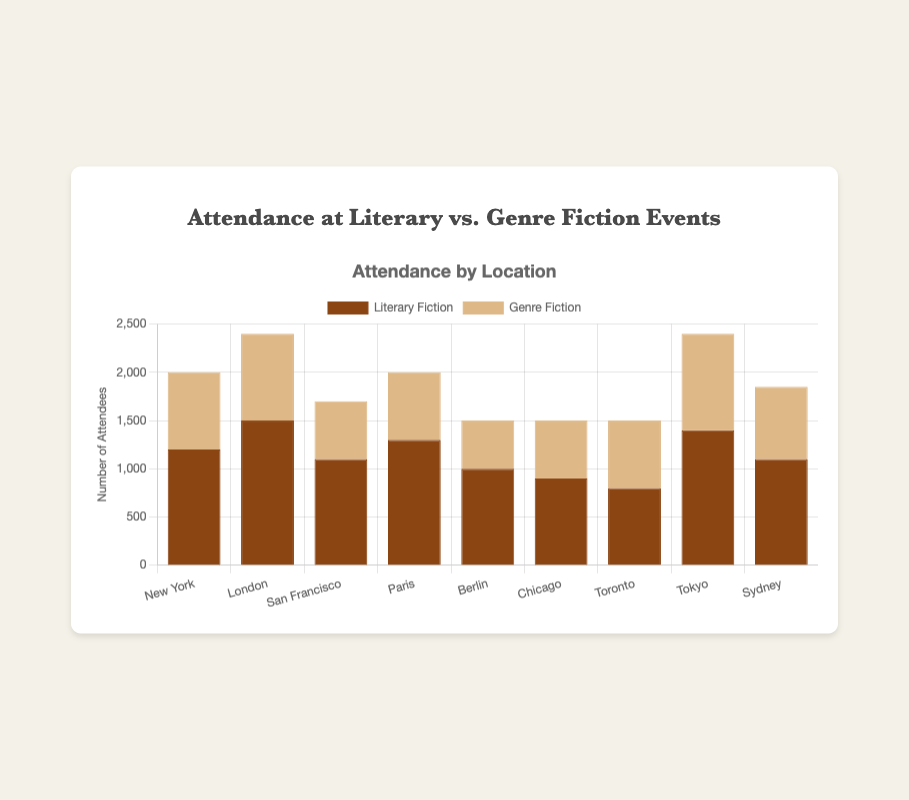What is the total attendance at Literary Fiction events across all locations? To find the total attendance at Literary Fiction events, sum the values for each location: 1200 + 1500 + 1100 + 1300 + 1000 + 900 + 800 + 1400 + 1100 = 11300
Answer: 11300 Which location has the highest attendance for Genre Fiction events? Compare the Genre Fiction attendance numbers for all locations. New York has 800, London has 900, San Francisco has 600, Paris has 700, Berlin has 500, Chicago has 600, Toronto has 700, Tokyo has 1000, and Sydney has 750. Tokyo has the highest at 1000
Answer: Tokyo What is the difference in attendance between Literary Fiction and Genre Fiction in Paris? Subtract the Genre Fiction attendance from Literary Fiction attendance in Paris. 1300 - 700 = 600
Answer: 600 In which location is the disparity between Literary and Genre Fiction attendance the smallest? Calculate the absolute difference in attendance between Literary and Genre Fiction for each location and compare. The differences are: New York: 400, London: 600, San Francisco: 500, Paris: 600, Berlin: 500, Chicago: 300, Toronto: 100, Tokyo: 400, Sydney: 350. Toronto has the smallest disparity with 100
Answer: Toronto What is the average attendance at Literary Fiction events across New York, London, and Tokyo? Sum the Literary Fiction attendance for New York, London, and Tokyo and divide by 3. (1200 + 1500 + 1400) / 3 = 1366.67
Answer: 1366.67 How many more people attended Literary Fiction events compared to Genre Fiction in San Francisco? Subtract the Genre Fiction attendance from Literary Fiction attendance in San Francisco. 1100 - 600 = 500
Answer: 500 Which location has the lowest combined attendance for both Literary and Genre Fiction events? Sum the attendance of Literary and Genre Fiction for each location and find the smallest sum. The sums are: New York: 2000, London: 2400, San Francisco: 1700, Paris: 2000, Berlin: 1500, Chicago: 1500, Toronto: 1500, Tokyo: 2400, Sydney: 1850. Berlin, Chicago, and Toronto each have the lowest combined attendance of 1500
Answer: Berlin, Chicago, Toronto Which type of fiction has a higher overall attendance across all locations, Literary or Genre? Sum the attendance for Literary Fiction across all locations and compare it to the sum for Genre Fiction. Literary Fiction: 1200 + 1500 + 1100 + 1300 + 1000 + 900 + 800 + 1400 + 1100 = 11300. Genre Fiction: 800 + 900 + 600 + 700 + 500 + 600 + 700 + 1000 + 750 = 6550. Literary Fiction has a higher overall attendance.
Answer: Literary Fiction In which location does Literary Fiction have the highest share of total fiction event attendance? Calculate the share of Literary Fiction attendance for each location by dividing Literary Fiction attendance by the total attendance and compare. New York: 1200/2000 = 0.6, London: 1500/2400 = 0.625, San Francisco: 1100/1700 = 0.647, Paris: 1300/2000 = 0.65, Berlin: 1000/1500 = 0.667, Chicago: 900/1500 = 0.6, Toronto: 800/1500 = 0.533, Tokyo: 1400/2400 = 0.583, Sydney: 1100/1850 = 0.595. Berlin has the highest share with 0.667
Answer: Berlin 